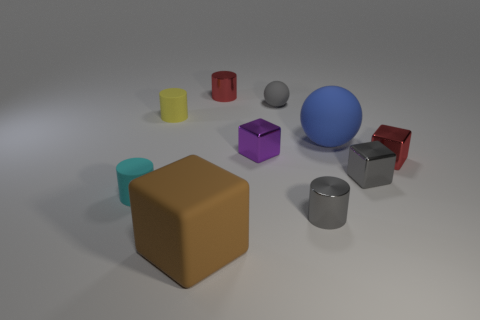There is a block on the left side of the shiny cylinder that is behind the cyan object; what size is it?
Give a very brief answer. Large. What is the material of the sphere that is the same size as the red metal cube?
Offer a very short reply. Rubber. What number of other things are there of the same size as the gray shiny cube?
Ensure brevity in your answer.  7. What number of blocks are red metal things or gray things?
Offer a terse response. 2. What material is the cube behind the tiny red metal thing right of the red shiny thing behind the large blue sphere?
Ensure brevity in your answer.  Metal. There is a cube that is the same color as the small matte sphere; what is it made of?
Make the answer very short. Metal. What number of small red cylinders are the same material as the red block?
Make the answer very short. 1. Is the size of the shiny cylinder that is behind the gray rubber ball the same as the small purple shiny thing?
Your answer should be very brief. Yes. The block that is made of the same material as the blue sphere is what color?
Ensure brevity in your answer.  Brown. There is a tiny cyan thing; how many small gray cylinders are behind it?
Offer a terse response. 0. 